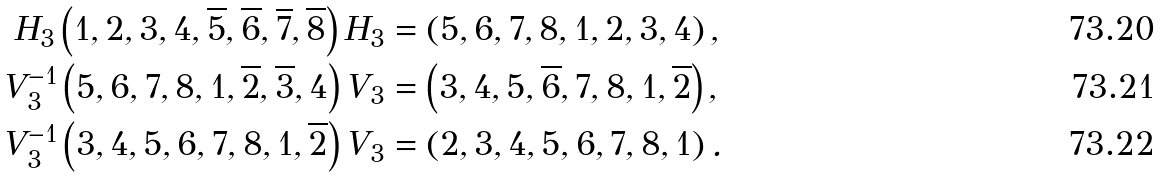<formula> <loc_0><loc_0><loc_500><loc_500>H _ { 3 } \left ( 1 , 2 , 3 , 4 , \overline { 5 } , \overline { 6 } , \overline { 7 } , \overline { 8 } \right ) H _ { 3 } & = \left ( 5 , 6 , 7 , 8 , 1 , 2 , 3 , 4 \right ) , \\ V _ { 3 } ^ { - 1 } \left ( 5 , 6 , 7 , 8 , 1 , \overline { 2 } , \overline { 3 } , 4 \right ) V _ { 3 } & = \left ( 3 , 4 , 5 , \overline { 6 } , 7 , 8 , 1 , \overline { 2 } \right ) , \\ V _ { 3 } ^ { - 1 } \left ( 3 , 4 , 5 , 6 , 7 , 8 , 1 , \overline { 2 } \right ) V _ { 3 } & = \left ( 2 , 3 , 4 , 5 , 6 , 7 , 8 , 1 \right ) .</formula> 